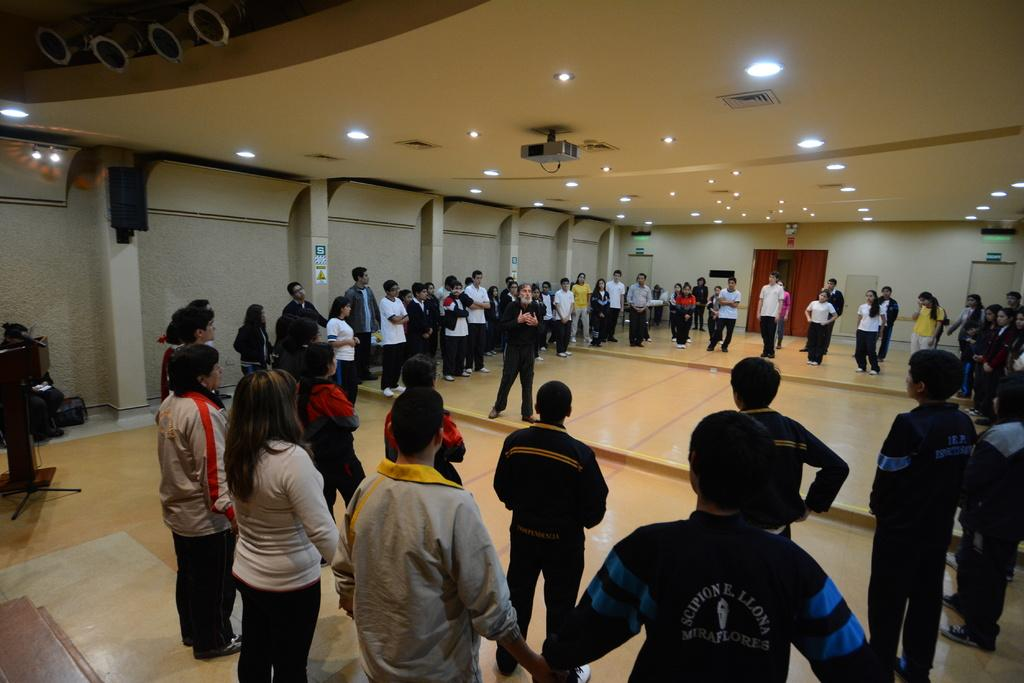How many people are in the image? There is a group of people in the image, but the exact number is not specified. What are the people doing in the image? The people are standing on the floor. What object can be seen near the people? There is a podium in the image. Who might be speaking in the image? There is a speaker in the image, so it is likely that they are speaking. What can be seen illuminating the scene? There are lights in the image. What is visible in the background of the image? There is a wall and curtains in the background of the image. What type of bag is being carried by the speaker in the image? There is no bag visible in the image, and the speaker is not mentioned as carrying one. 